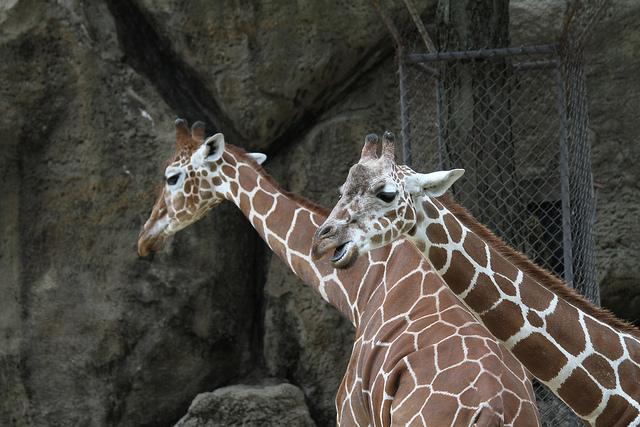How many giraffes are there?
Concise answer only. 2. Is there a fence?
Give a very brief answer. Yes. Are the giraffes eating?
Quick response, please. No. 